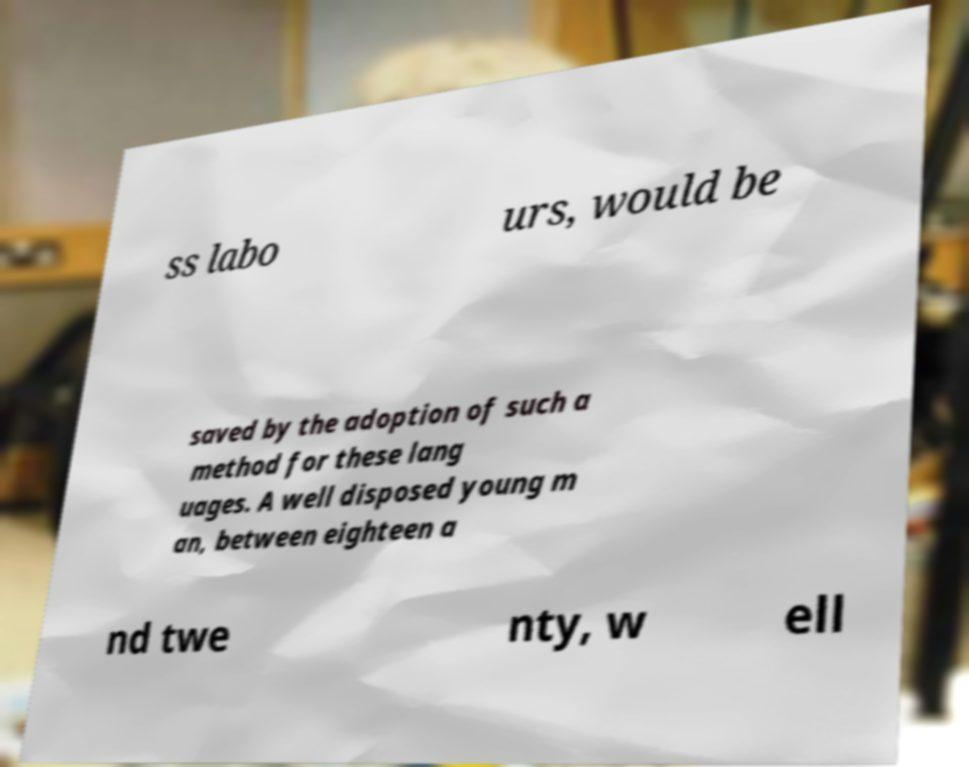Please read and relay the text visible in this image. What does it say? ss labo urs, would be saved by the adoption of such a method for these lang uages. A well disposed young m an, between eighteen a nd twe nty, w ell 